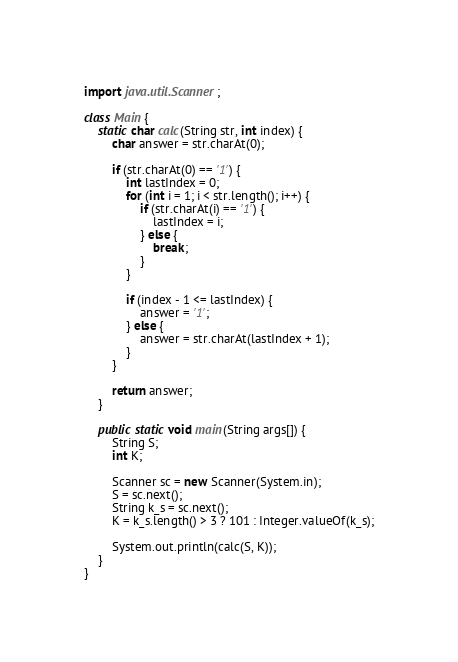<code> <loc_0><loc_0><loc_500><loc_500><_Java_>import java.util.Scanner;

class Main {
    static char calc(String str, int index) {
        char answer = str.charAt(0);

        if (str.charAt(0) == '1') {
            int lastIndex = 0;
            for (int i = 1; i < str.length(); i++) {
                if (str.charAt(i) == '1') {
                    lastIndex = i;
                } else {
                    break;
                }
            }

            if (index - 1 <= lastIndex) {
                answer = '1';
            } else {
                answer = str.charAt(lastIndex + 1);
            }
        }

        return answer;
    }

    public static void main(String args[]) {
        String S;
        int K;

        Scanner sc = new Scanner(System.in);
        S = sc.next();
        String k_s = sc.next();
        K = k_s.length() > 3 ? 101 : Integer.valueOf(k_s);

        System.out.println(calc(S, K));
    }
}
</code> 